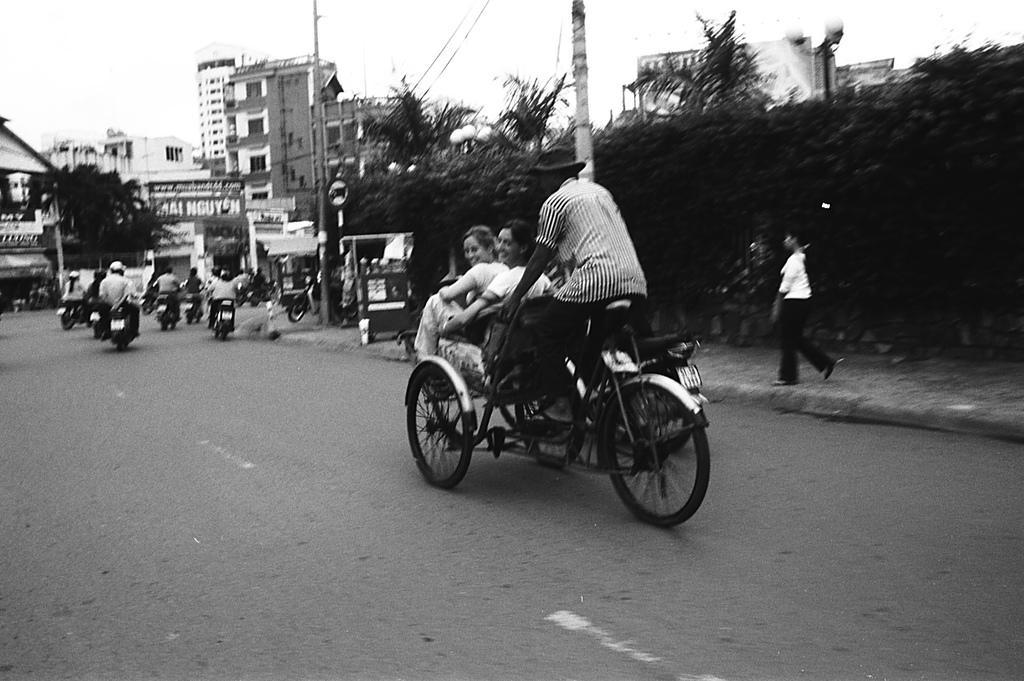Please provide a concise description of this image. In this picture there is a man who is riding the bicycle cart and there are two girls those who are sitting in front of, there some trees around the area of the image and there is a building at the left side of the image its seems to be a street view. 